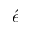<formula> <loc_0><loc_0><loc_500><loc_500>\acute { e }</formula> 